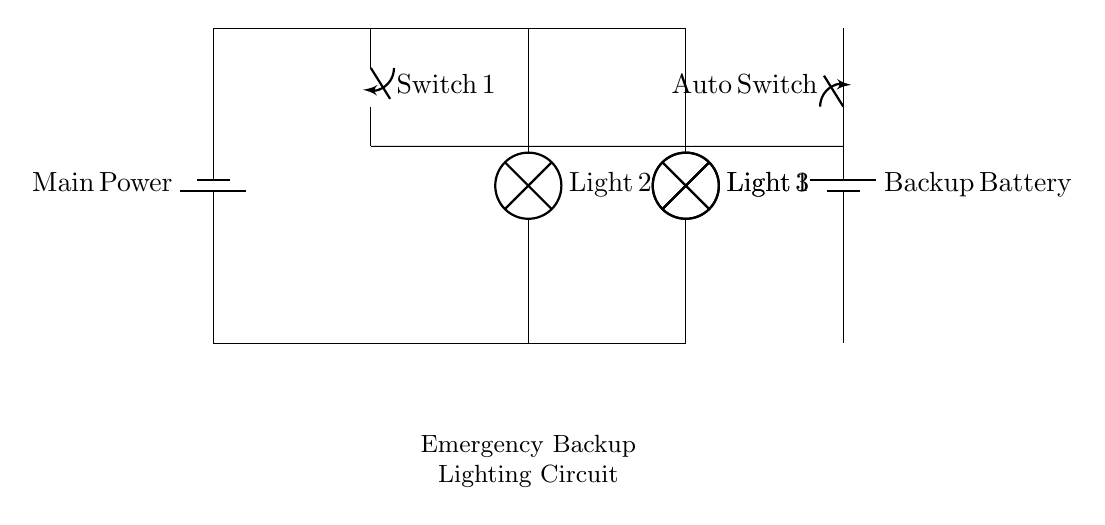What type of circuit is shown? The circuit is a parallel circuit, indicated by multiple branches from the same power source. In a parallel configuration, components are connected across common points, allowing them to operate independently.
Answer: parallel circuit How many lamps are in this circuit? The circuit diagram includes three lamps, as indicated by the three distinct lamp symbols within the circuit. Each lamp is connected in parallel to the main power and backup battery.
Answer: three lamps What component automatically switches to backup power? The component designated as "Auto Switch" automatically connects the circuit to the backup battery when the main power is lost. This switch detects the loss and changes the circuit configuration to ensure continuous lighting.
Answer: Auto Switch What is the main power source? The main power source is the "Main Power" battery depicted at the top left of the circuit diagram. This battery provides electricity to the circuit and is essential for the operation of connected components.
Answer: Main Power What is the purpose of the switch labeled "Switch 1"? The switch labeled "Switch 1" is used to manually control the connection to the lamps, allowing the user to turn the lamps on or off as needed. It can enable or disable power flow to the lower branch of the circuit.
Answer: manual control What happens when the main power fails? When the main power fails, the Auto Switch activates, redirecting the power supply from the backup battery to the lamps, thus ensuring they remain lit during an emergency. This automatic response is crucial for emergency lighting systems.
Answer: switches to backup What is the voltage source of the backup? The backup source is also a "Backup Battery" depicted in the circuit, which provides energy in case the main power source fails. The voltage of the backup battery is the same as that of the main power unless specified otherwise.
Answer: Backup Battery 